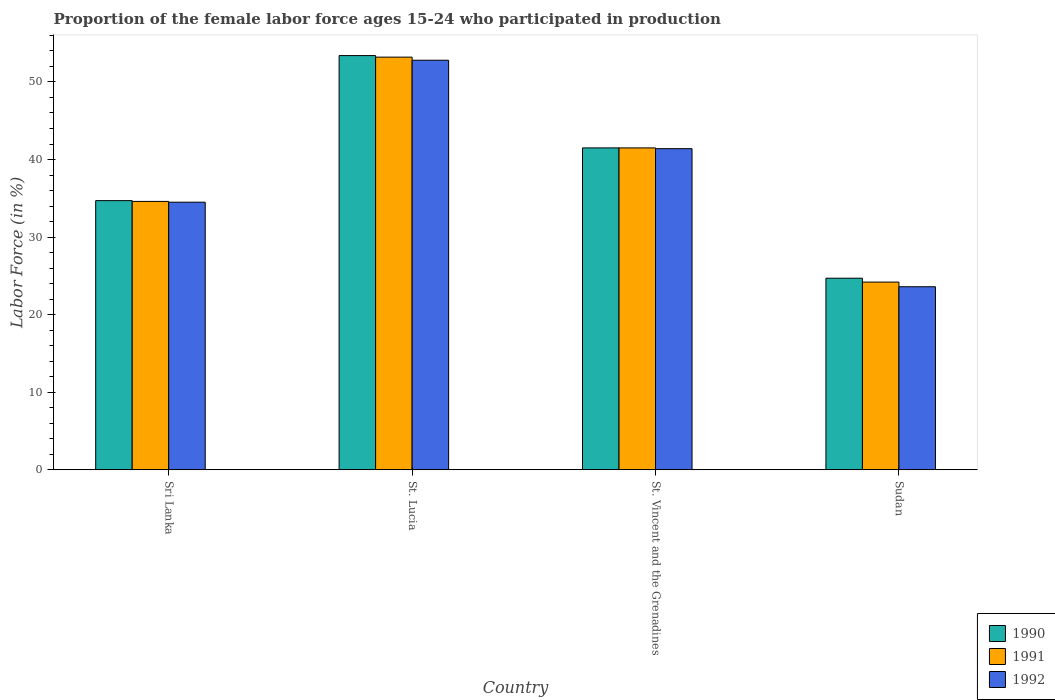How many bars are there on the 1st tick from the left?
Provide a succinct answer. 3. How many bars are there on the 4th tick from the right?
Offer a very short reply. 3. What is the label of the 3rd group of bars from the left?
Offer a very short reply. St. Vincent and the Grenadines. What is the proportion of the female labor force who participated in production in 1992 in St. Lucia?
Your answer should be very brief. 52.8. Across all countries, what is the maximum proportion of the female labor force who participated in production in 1991?
Make the answer very short. 53.2. Across all countries, what is the minimum proportion of the female labor force who participated in production in 1991?
Ensure brevity in your answer.  24.2. In which country was the proportion of the female labor force who participated in production in 1992 maximum?
Ensure brevity in your answer.  St. Lucia. In which country was the proportion of the female labor force who participated in production in 1992 minimum?
Your answer should be compact. Sudan. What is the total proportion of the female labor force who participated in production in 1991 in the graph?
Make the answer very short. 153.5. What is the difference between the proportion of the female labor force who participated in production in 1991 in Sri Lanka and that in St. Lucia?
Offer a very short reply. -18.6. What is the difference between the proportion of the female labor force who participated in production in 1991 in Sri Lanka and the proportion of the female labor force who participated in production in 1992 in Sudan?
Ensure brevity in your answer.  11. What is the average proportion of the female labor force who participated in production in 1990 per country?
Your answer should be compact. 38.58. What is the difference between the proportion of the female labor force who participated in production of/in 1991 and proportion of the female labor force who participated in production of/in 1992 in St. Lucia?
Keep it short and to the point. 0.4. In how many countries, is the proportion of the female labor force who participated in production in 1992 greater than 48 %?
Offer a very short reply. 1. What is the ratio of the proportion of the female labor force who participated in production in 1990 in St. Lucia to that in St. Vincent and the Grenadines?
Your answer should be compact. 1.29. What is the difference between the highest and the second highest proportion of the female labor force who participated in production in 1992?
Ensure brevity in your answer.  6.9. What is the difference between the highest and the lowest proportion of the female labor force who participated in production in 1991?
Keep it short and to the point. 29. What does the 1st bar from the right in St. Vincent and the Grenadines represents?
Give a very brief answer. 1992. Are all the bars in the graph horizontal?
Your answer should be very brief. No. What is the difference between two consecutive major ticks on the Y-axis?
Ensure brevity in your answer.  10. Are the values on the major ticks of Y-axis written in scientific E-notation?
Make the answer very short. No. Does the graph contain grids?
Offer a terse response. No. What is the title of the graph?
Ensure brevity in your answer.  Proportion of the female labor force ages 15-24 who participated in production. Does "1973" appear as one of the legend labels in the graph?
Your answer should be compact. No. What is the label or title of the X-axis?
Your answer should be very brief. Country. What is the Labor Force (in %) in 1990 in Sri Lanka?
Give a very brief answer. 34.7. What is the Labor Force (in %) in 1991 in Sri Lanka?
Your response must be concise. 34.6. What is the Labor Force (in %) in 1992 in Sri Lanka?
Offer a terse response. 34.5. What is the Labor Force (in %) in 1990 in St. Lucia?
Provide a succinct answer. 53.4. What is the Labor Force (in %) in 1991 in St. Lucia?
Your answer should be compact. 53.2. What is the Labor Force (in %) of 1992 in St. Lucia?
Your answer should be compact. 52.8. What is the Labor Force (in %) in 1990 in St. Vincent and the Grenadines?
Give a very brief answer. 41.5. What is the Labor Force (in %) of 1991 in St. Vincent and the Grenadines?
Make the answer very short. 41.5. What is the Labor Force (in %) in 1992 in St. Vincent and the Grenadines?
Keep it short and to the point. 41.4. What is the Labor Force (in %) of 1990 in Sudan?
Make the answer very short. 24.7. What is the Labor Force (in %) of 1991 in Sudan?
Offer a very short reply. 24.2. What is the Labor Force (in %) of 1992 in Sudan?
Give a very brief answer. 23.6. Across all countries, what is the maximum Labor Force (in %) in 1990?
Your response must be concise. 53.4. Across all countries, what is the maximum Labor Force (in %) in 1991?
Your answer should be compact. 53.2. Across all countries, what is the maximum Labor Force (in %) of 1992?
Provide a short and direct response. 52.8. Across all countries, what is the minimum Labor Force (in %) of 1990?
Your response must be concise. 24.7. Across all countries, what is the minimum Labor Force (in %) of 1991?
Provide a short and direct response. 24.2. Across all countries, what is the minimum Labor Force (in %) of 1992?
Offer a terse response. 23.6. What is the total Labor Force (in %) in 1990 in the graph?
Your answer should be compact. 154.3. What is the total Labor Force (in %) in 1991 in the graph?
Provide a succinct answer. 153.5. What is the total Labor Force (in %) in 1992 in the graph?
Provide a succinct answer. 152.3. What is the difference between the Labor Force (in %) of 1990 in Sri Lanka and that in St. Lucia?
Offer a terse response. -18.7. What is the difference between the Labor Force (in %) in 1991 in Sri Lanka and that in St. Lucia?
Give a very brief answer. -18.6. What is the difference between the Labor Force (in %) of 1992 in Sri Lanka and that in St. Lucia?
Your response must be concise. -18.3. What is the difference between the Labor Force (in %) in 1990 in Sri Lanka and that in St. Vincent and the Grenadines?
Your answer should be compact. -6.8. What is the difference between the Labor Force (in %) of 1991 in Sri Lanka and that in St. Vincent and the Grenadines?
Keep it short and to the point. -6.9. What is the difference between the Labor Force (in %) of 1991 in Sri Lanka and that in Sudan?
Make the answer very short. 10.4. What is the difference between the Labor Force (in %) of 1992 in Sri Lanka and that in Sudan?
Your answer should be very brief. 10.9. What is the difference between the Labor Force (in %) in 1990 in St. Lucia and that in St. Vincent and the Grenadines?
Ensure brevity in your answer.  11.9. What is the difference between the Labor Force (in %) in 1991 in St. Lucia and that in St. Vincent and the Grenadines?
Ensure brevity in your answer.  11.7. What is the difference between the Labor Force (in %) of 1992 in St. Lucia and that in St. Vincent and the Grenadines?
Offer a very short reply. 11.4. What is the difference between the Labor Force (in %) of 1990 in St. Lucia and that in Sudan?
Your answer should be very brief. 28.7. What is the difference between the Labor Force (in %) in 1991 in St. Lucia and that in Sudan?
Provide a short and direct response. 29. What is the difference between the Labor Force (in %) of 1992 in St. Lucia and that in Sudan?
Make the answer very short. 29.2. What is the difference between the Labor Force (in %) of 1990 in St. Vincent and the Grenadines and that in Sudan?
Offer a very short reply. 16.8. What is the difference between the Labor Force (in %) in 1990 in Sri Lanka and the Labor Force (in %) in 1991 in St. Lucia?
Provide a succinct answer. -18.5. What is the difference between the Labor Force (in %) of 1990 in Sri Lanka and the Labor Force (in %) of 1992 in St. Lucia?
Give a very brief answer. -18.1. What is the difference between the Labor Force (in %) of 1991 in Sri Lanka and the Labor Force (in %) of 1992 in St. Lucia?
Offer a very short reply. -18.2. What is the difference between the Labor Force (in %) in 1990 in Sri Lanka and the Labor Force (in %) in 1991 in St. Vincent and the Grenadines?
Your answer should be very brief. -6.8. What is the difference between the Labor Force (in %) in 1991 in Sri Lanka and the Labor Force (in %) in 1992 in St. Vincent and the Grenadines?
Provide a short and direct response. -6.8. What is the difference between the Labor Force (in %) of 1990 in Sri Lanka and the Labor Force (in %) of 1991 in Sudan?
Your answer should be compact. 10.5. What is the difference between the Labor Force (in %) in 1991 in Sri Lanka and the Labor Force (in %) in 1992 in Sudan?
Offer a very short reply. 11. What is the difference between the Labor Force (in %) in 1990 in St. Lucia and the Labor Force (in %) in 1991 in St. Vincent and the Grenadines?
Offer a terse response. 11.9. What is the difference between the Labor Force (in %) of 1990 in St. Lucia and the Labor Force (in %) of 1992 in St. Vincent and the Grenadines?
Offer a very short reply. 12. What is the difference between the Labor Force (in %) of 1990 in St. Lucia and the Labor Force (in %) of 1991 in Sudan?
Your response must be concise. 29.2. What is the difference between the Labor Force (in %) in 1990 in St. Lucia and the Labor Force (in %) in 1992 in Sudan?
Offer a very short reply. 29.8. What is the difference between the Labor Force (in %) of 1991 in St. Lucia and the Labor Force (in %) of 1992 in Sudan?
Provide a short and direct response. 29.6. What is the difference between the Labor Force (in %) in 1990 in St. Vincent and the Grenadines and the Labor Force (in %) in 1992 in Sudan?
Your answer should be compact. 17.9. What is the difference between the Labor Force (in %) in 1991 in St. Vincent and the Grenadines and the Labor Force (in %) in 1992 in Sudan?
Provide a short and direct response. 17.9. What is the average Labor Force (in %) of 1990 per country?
Provide a succinct answer. 38.58. What is the average Labor Force (in %) of 1991 per country?
Your answer should be compact. 38.38. What is the average Labor Force (in %) in 1992 per country?
Provide a short and direct response. 38.08. What is the difference between the Labor Force (in %) in 1990 and Labor Force (in %) in 1991 in Sri Lanka?
Ensure brevity in your answer.  0.1. What is the difference between the Labor Force (in %) of 1990 and Labor Force (in %) of 1992 in Sri Lanka?
Your response must be concise. 0.2. What is the difference between the Labor Force (in %) of 1990 and Labor Force (in %) of 1991 in St. Vincent and the Grenadines?
Your answer should be very brief. 0. What is the difference between the Labor Force (in %) in 1990 and Labor Force (in %) in 1992 in St. Vincent and the Grenadines?
Your response must be concise. 0.1. What is the difference between the Labor Force (in %) in 1991 and Labor Force (in %) in 1992 in St. Vincent and the Grenadines?
Offer a very short reply. 0.1. What is the difference between the Labor Force (in %) of 1990 and Labor Force (in %) of 1992 in Sudan?
Your answer should be compact. 1.1. What is the ratio of the Labor Force (in %) of 1990 in Sri Lanka to that in St. Lucia?
Offer a very short reply. 0.65. What is the ratio of the Labor Force (in %) in 1991 in Sri Lanka to that in St. Lucia?
Make the answer very short. 0.65. What is the ratio of the Labor Force (in %) in 1992 in Sri Lanka to that in St. Lucia?
Make the answer very short. 0.65. What is the ratio of the Labor Force (in %) in 1990 in Sri Lanka to that in St. Vincent and the Grenadines?
Your response must be concise. 0.84. What is the ratio of the Labor Force (in %) of 1991 in Sri Lanka to that in St. Vincent and the Grenadines?
Offer a terse response. 0.83. What is the ratio of the Labor Force (in %) in 1992 in Sri Lanka to that in St. Vincent and the Grenadines?
Offer a terse response. 0.83. What is the ratio of the Labor Force (in %) in 1990 in Sri Lanka to that in Sudan?
Offer a terse response. 1.4. What is the ratio of the Labor Force (in %) in 1991 in Sri Lanka to that in Sudan?
Provide a succinct answer. 1.43. What is the ratio of the Labor Force (in %) in 1992 in Sri Lanka to that in Sudan?
Keep it short and to the point. 1.46. What is the ratio of the Labor Force (in %) in 1990 in St. Lucia to that in St. Vincent and the Grenadines?
Keep it short and to the point. 1.29. What is the ratio of the Labor Force (in %) in 1991 in St. Lucia to that in St. Vincent and the Grenadines?
Offer a very short reply. 1.28. What is the ratio of the Labor Force (in %) in 1992 in St. Lucia to that in St. Vincent and the Grenadines?
Your response must be concise. 1.28. What is the ratio of the Labor Force (in %) in 1990 in St. Lucia to that in Sudan?
Offer a terse response. 2.16. What is the ratio of the Labor Force (in %) in 1991 in St. Lucia to that in Sudan?
Your answer should be compact. 2.2. What is the ratio of the Labor Force (in %) of 1992 in St. Lucia to that in Sudan?
Provide a short and direct response. 2.24. What is the ratio of the Labor Force (in %) in 1990 in St. Vincent and the Grenadines to that in Sudan?
Make the answer very short. 1.68. What is the ratio of the Labor Force (in %) of 1991 in St. Vincent and the Grenadines to that in Sudan?
Your response must be concise. 1.71. What is the ratio of the Labor Force (in %) in 1992 in St. Vincent and the Grenadines to that in Sudan?
Give a very brief answer. 1.75. What is the difference between the highest and the second highest Labor Force (in %) of 1990?
Provide a succinct answer. 11.9. What is the difference between the highest and the second highest Labor Force (in %) of 1991?
Provide a short and direct response. 11.7. What is the difference between the highest and the lowest Labor Force (in %) in 1990?
Make the answer very short. 28.7. What is the difference between the highest and the lowest Labor Force (in %) in 1992?
Offer a terse response. 29.2. 